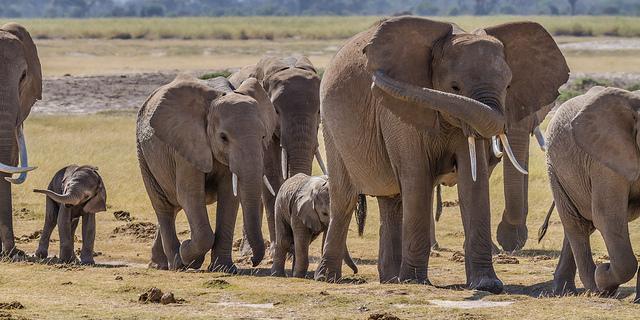How many elephants are not adults?
Give a very brief answer. 2. How many total elephants are visible?
Give a very brief answer. 7. How many elephants are there?
Give a very brief answer. 8. How many standing cows are there in the image ?
Give a very brief answer. 0. 